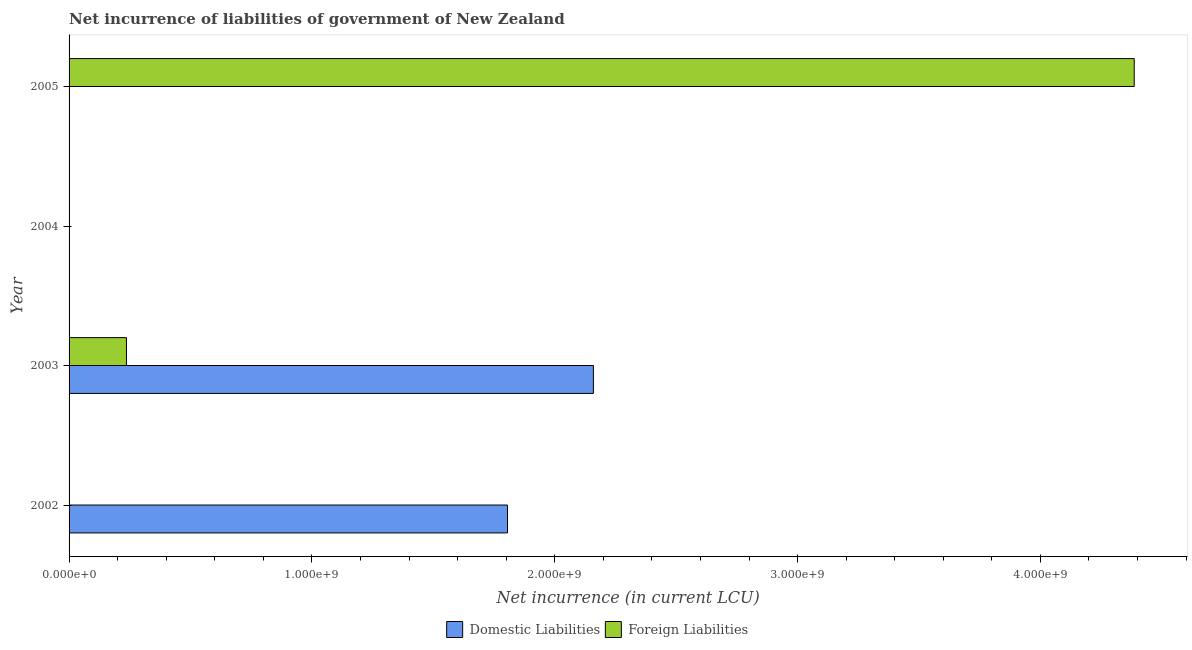How many different coloured bars are there?
Offer a very short reply. 2. Are the number of bars per tick equal to the number of legend labels?
Your answer should be compact. No. How many bars are there on the 3rd tick from the top?
Provide a short and direct response. 2. In how many cases, is the number of bars for a given year not equal to the number of legend labels?
Keep it short and to the point. 3. What is the net incurrence of foreign liabilities in 2005?
Offer a terse response. 4.39e+09. Across all years, what is the maximum net incurrence of foreign liabilities?
Ensure brevity in your answer.  4.39e+09. In which year was the net incurrence of domestic liabilities maximum?
Your answer should be compact. 2003. What is the total net incurrence of domestic liabilities in the graph?
Offer a terse response. 3.96e+09. What is the difference between the net incurrence of domestic liabilities in 2002 and that in 2003?
Keep it short and to the point. -3.54e+08. What is the difference between the net incurrence of domestic liabilities in 2005 and the net incurrence of foreign liabilities in 2002?
Provide a short and direct response. 0. What is the average net incurrence of foreign liabilities per year?
Your response must be concise. 1.16e+09. In the year 2003, what is the difference between the net incurrence of foreign liabilities and net incurrence of domestic liabilities?
Your response must be concise. -1.92e+09. What is the ratio of the net incurrence of foreign liabilities in 2003 to that in 2005?
Your answer should be compact. 0.05. What is the difference between the highest and the lowest net incurrence of domestic liabilities?
Ensure brevity in your answer.  2.16e+09. In how many years, is the net incurrence of foreign liabilities greater than the average net incurrence of foreign liabilities taken over all years?
Give a very brief answer. 1. Is the sum of the net incurrence of foreign liabilities in 2003 and 2005 greater than the maximum net incurrence of domestic liabilities across all years?
Make the answer very short. Yes. How many bars are there?
Your answer should be compact. 4. How many years are there in the graph?
Offer a very short reply. 4. Are the values on the major ticks of X-axis written in scientific E-notation?
Provide a succinct answer. Yes. Does the graph contain grids?
Provide a succinct answer. No. Where does the legend appear in the graph?
Offer a very short reply. Bottom center. What is the title of the graph?
Provide a succinct answer. Net incurrence of liabilities of government of New Zealand. What is the label or title of the X-axis?
Offer a very short reply. Net incurrence (in current LCU). What is the Net incurrence (in current LCU) in Domestic Liabilities in 2002?
Ensure brevity in your answer.  1.81e+09. What is the Net incurrence (in current LCU) in Domestic Liabilities in 2003?
Make the answer very short. 2.16e+09. What is the Net incurrence (in current LCU) of Foreign Liabilities in 2003?
Offer a terse response. 2.36e+08. What is the Net incurrence (in current LCU) in Domestic Liabilities in 2004?
Provide a succinct answer. 0. What is the Net incurrence (in current LCU) of Foreign Liabilities in 2004?
Make the answer very short. 0. What is the Net incurrence (in current LCU) of Foreign Liabilities in 2005?
Your answer should be very brief. 4.39e+09. Across all years, what is the maximum Net incurrence (in current LCU) of Domestic Liabilities?
Your answer should be very brief. 2.16e+09. Across all years, what is the maximum Net incurrence (in current LCU) of Foreign Liabilities?
Provide a short and direct response. 4.39e+09. Across all years, what is the minimum Net incurrence (in current LCU) of Domestic Liabilities?
Make the answer very short. 0. Across all years, what is the minimum Net incurrence (in current LCU) in Foreign Liabilities?
Ensure brevity in your answer.  0. What is the total Net incurrence (in current LCU) of Domestic Liabilities in the graph?
Your response must be concise. 3.96e+09. What is the total Net incurrence (in current LCU) in Foreign Liabilities in the graph?
Make the answer very short. 4.62e+09. What is the difference between the Net incurrence (in current LCU) of Domestic Liabilities in 2002 and that in 2003?
Ensure brevity in your answer.  -3.54e+08. What is the difference between the Net incurrence (in current LCU) of Foreign Liabilities in 2003 and that in 2005?
Your answer should be compact. -4.15e+09. What is the difference between the Net incurrence (in current LCU) of Domestic Liabilities in 2002 and the Net incurrence (in current LCU) of Foreign Liabilities in 2003?
Make the answer very short. 1.57e+09. What is the difference between the Net incurrence (in current LCU) in Domestic Liabilities in 2002 and the Net incurrence (in current LCU) in Foreign Liabilities in 2005?
Ensure brevity in your answer.  -2.58e+09. What is the difference between the Net incurrence (in current LCU) in Domestic Liabilities in 2003 and the Net incurrence (in current LCU) in Foreign Liabilities in 2005?
Provide a short and direct response. -2.23e+09. What is the average Net incurrence (in current LCU) in Domestic Liabilities per year?
Your answer should be compact. 9.91e+08. What is the average Net incurrence (in current LCU) of Foreign Liabilities per year?
Keep it short and to the point. 1.16e+09. In the year 2003, what is the difference between the Net incurrence (in current LCU) in Domestic Liabilities and Net incurrence (in current LCU) in Foreign Liabilities?
Offer a very short reply. 1.92e+09. What is the ratio of the Net incurrence (in current LCU) of Domestic Liabilities in 2002 to that in 2003?
Provide a succinct answer. 0.84. What is the ratio of the Net incurrence (in current LCU) in Foreign Liabilities in 2003 to that in 2005?
Your answer should be very brief. 0.05. What is the difference between the highest and the lowest Net incurrence (in current LCU) of Domestic Liabilities?
Make the answer very short. 2.16e+09. What is the difference between the highest and the lowest Net incurrence (in current LCU) of Foreign Liabilities?
Provide a succinct answer. 4.39e+09. 